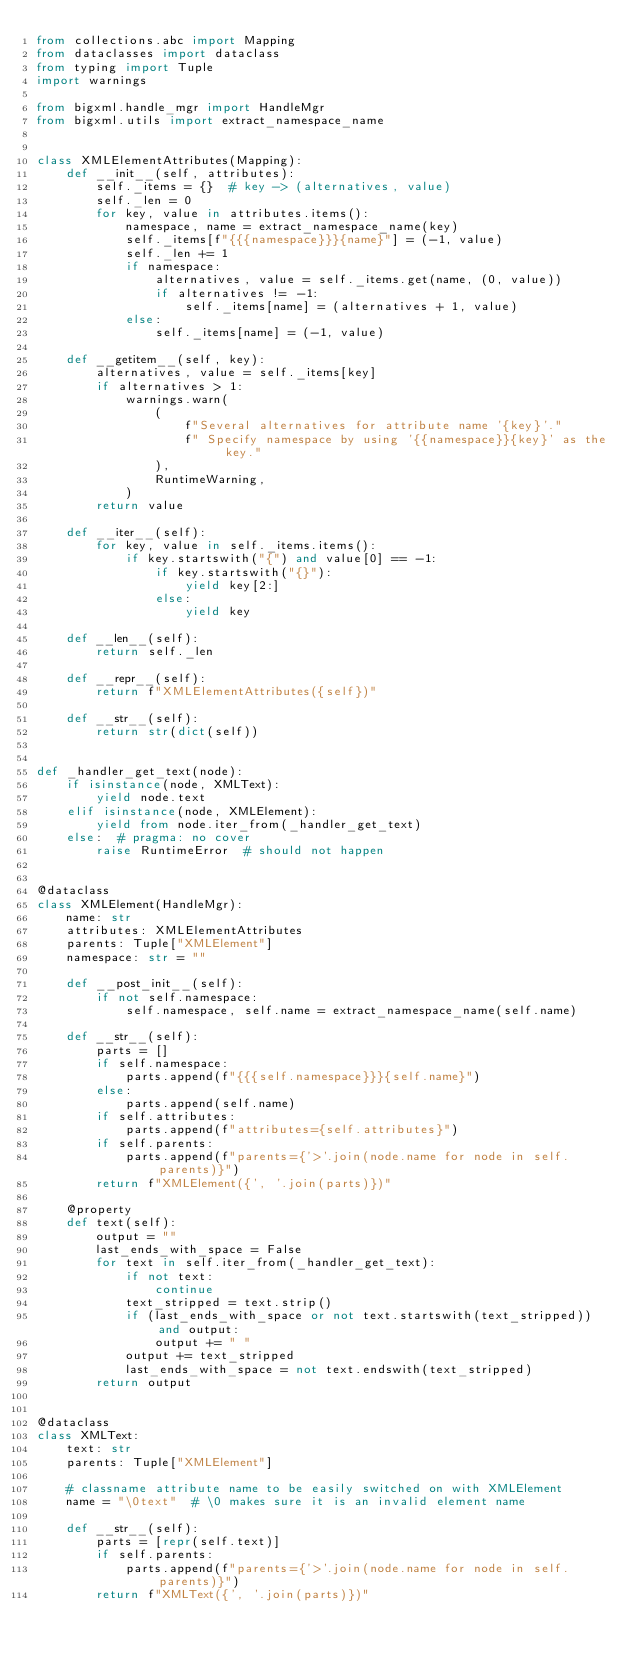<code> <loc_0><loc_0><loc_500><loc_500><_Python_>from collections.abc import Mapping
from dataclasses import dataclass
from typing import Tuple
import warnings

from bigxml.handle_mgr import HandleMgr
from bigxml.utils import extract_namespace_name


class XMLElementAttributes(Mapping):
    def __init__(self, attributes):
        self._items = {}  # key -> (alternatives, value)
        self._len = 0
        for key, value in attributes.items():
            namespace, name = extract_namespace_name(key)
            self._items[f"{{{namespace}}}{name}"] = (-1, value)
            self._len += 1
            if namespace:
                alternatives, value = self._items.get(name, (0, value))
                if alternatives != -1:
                    self._items[name] = (alternatives + 1, value)
            else:
                self._items[name] = (-1, value)

    def __getitem__(self, key):
        alternatives, value = self._items[key]
        if alternatives > 1:
            warnings.warn(
                (
                    f"Several alternatives for attribute name '{key}'."
                    f" Specify namespace by using '{{namespace}}{key}' as the key."
                ),
                RuntimeWarning,
            )
        return value

    def __iter__(self):
        for key, value in self._items.items():
            if key.startswith("{") and value[0] == -1:
                if key.startswith("{}"):
                    yield key[2:]
                else:
                    yield key

    def __len__(self):
        return self._len

    def __repr__(self):
        return f"XMLElementAttributes({self})"

    def __str__(self):
        return str(dict(self))


def _handler_get_text(node):
    if isinstance(node, XMLText):
        yield node.text
    elif isinstance(node, XMLElement):
        yield from node.iter_from(_handler_get_text)
    else:  # pragma: no cover
        raise RuntimeError  # should not happen


@dataclass
class XMLElement(HandleMgr):
    name: str
    attributes: XMLElementAttributes
    parents: Tuple["XMLElement"]
    namespace: str = ""

    def __post_init__(self):
        if not self.namespace:
            self.namespace, self.name = extract_namespace_name(self.name)

    def __str__(self):
        parts = []
        if self.namespace:
            parts.append(f"{{{self.namespace}}}{self.name}")
        else:
            parts.append(self.name)
        if self.attributes:
            parts.append(f"attributes={self.attributes}")
        if self.parents:
            parts.append(f"parents={'>'.join(node.name for node in self.parents)}")
        return f"XMLElement({', '.join(parts)})"

    @property
    def text(self):
        output = ""
        last_ends_with_space = False
        for text in self.iter_from(_handler_get_text):
            if not text:
                continue
            text_stripped = text.strip()
            if (last_ends_with_space or not text.startswith(text_stripped)) and output:
                output += " "
            output += text_stripped
            last_ends_with_space = not text.endswith(text_stripped)
        return output


@dataclass
class XMLText:
    text: str
    parents: Tuple["XMLElement"]

    # classname attribute name to be easily switched on with XMLElement
    name = "\0text"  # \0 makes sure it is an invalid element name

    def __str__(self):
        parts = [repr(self.text)]
        if self.parents:
            parts.append(f"parents={'>'.join(node.name for node in self.parents)}")
        return f"XMLText({', '.join(parts)})"
</code> 